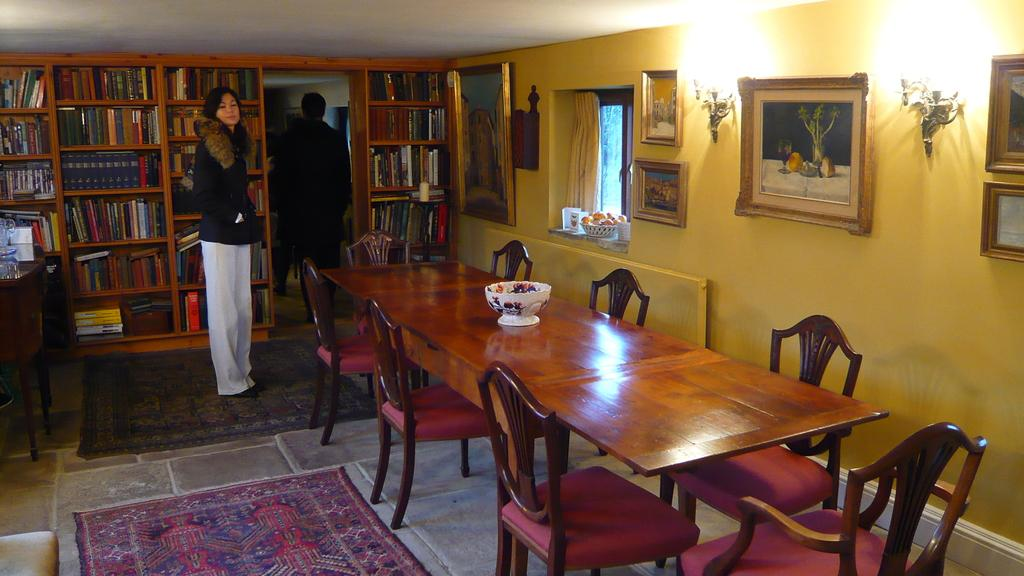How many people are in the image? There is a woman and a man in the image. What can be seen in the background of the image? There is a bookshelf with many books and a dining table in the image. Are there any decorative items on the wall in the image? Yes, there are photo frames on the wall in the image. What type of spring is visible in the image? There is no spring present in the image. Can you describe the mindset of the people in the image? The image does not provide any information about the mindset of the people; it only shows their physical appearance and the objects around them. 